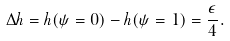Convert formula to latex. <formula><loc_0><loc_0><loc_500><loc_500>\Delta h = h ( \psi = 0 ) - h ( \psi = 1 ) = \frac { \epsilon } { 4 } .</formula> 